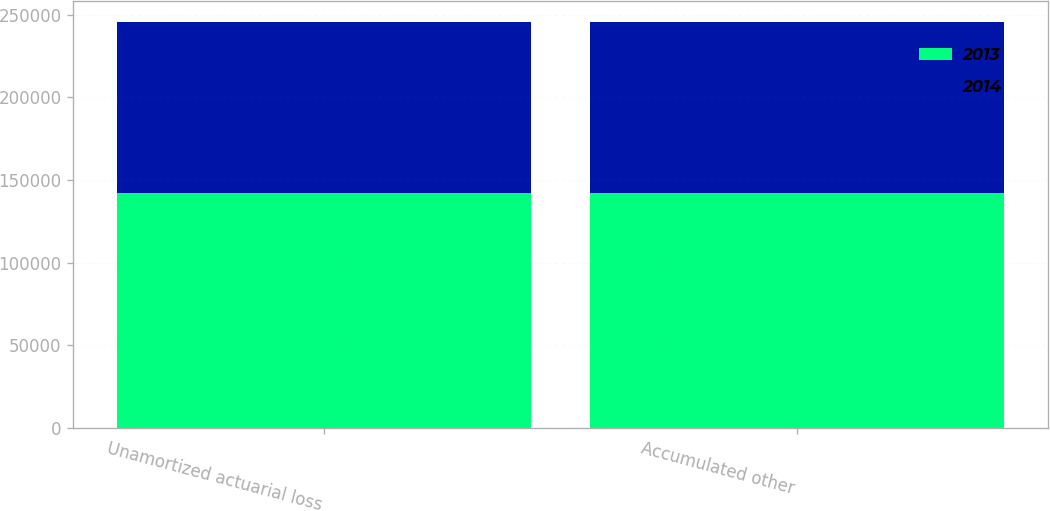<chart> <loc_0><loc_0><loc_500><loc_500><stacked_bar_chart><ecel><fcel>Unamortized actuarial loss<fcel>Accumulated other<nl><fcel>2013<fcel>141912<fcel>141912<nl><fcel>2014<fcel>103968<fcel>103968<nl></chart> 